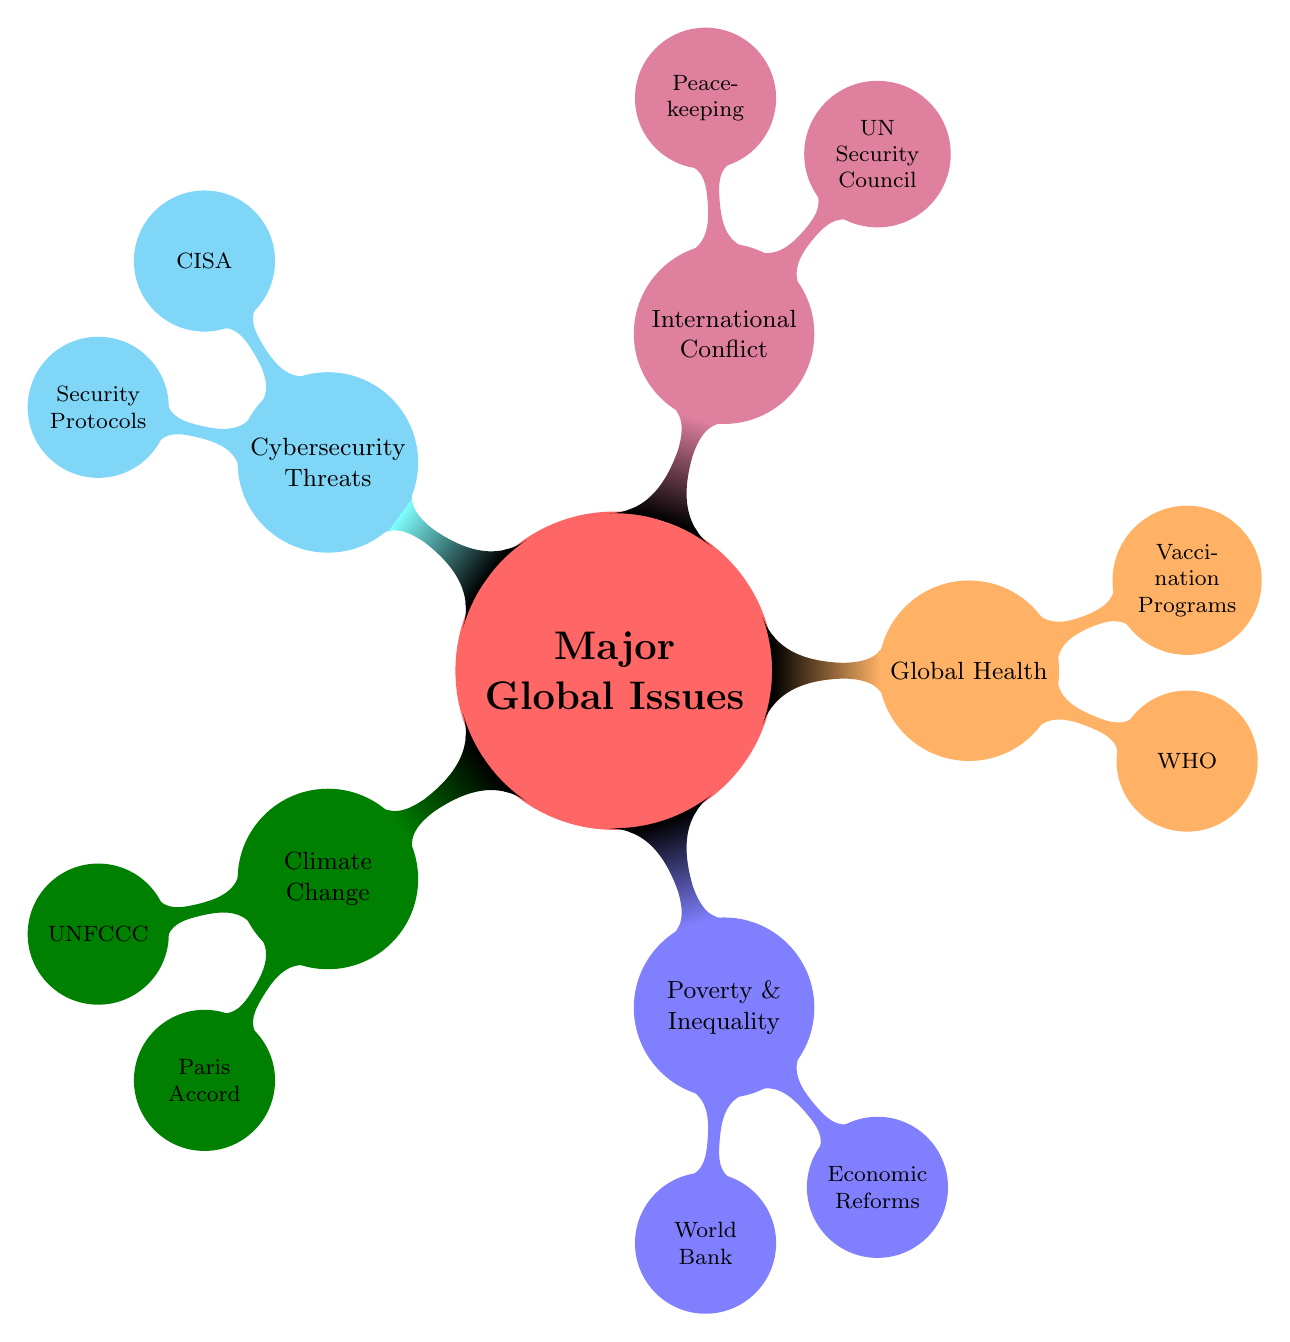What is the first major global issue listed in the diagram? The first issue appears at the top of the mind map under the title "Major Global Issues." It is labeled as "Climate Change."
Answer: Climate Change How many key organizations are listed under "Global Health"? The node for "Global Health" has three child nodes connected to it, which represent the key organizations, thereby indicating the number is three.
Answer: 3 Which organization is associated with "Poverty & Inequality"? The "Poverty & Inequality" node has a child node labeled "World Bank," making it a primary organization associated with this issue.
Answer: World Bank What are the two key solutions mentioned under "International Conflict"? Under the "International Conflict" node, there are two child nodes: "Peacekeeping missions" and "Diplomatic interventions," which are the solutions presented.
Answer: Peacekeeping missions, Diplomatic interventions Which global issue has the key organization "CISA"? The node labeled for "Cybersecurity Threats" directly connects to the child node with "CISA," which makes it the relevant global issue associated with that organization.
Answer: Cybersecurity Threats How many main issues are identified in the diagram? The diagram has five branches stemming from the main node "Major Global Issues," indicating that there are five identified major issues.
Answer: 5 Which major global issue includes "Universal healthcare access" in its solutions? Looking at the solutions under each issue, "Universal healthcare access" is listed as one of the key solutions under the "Global Health" node.
Answer: Global Health What is the purpose of the "Intergovernmental Panel on Climate Change" according to the diagram? The diagram does not explicitly state the purpose of the "Intergovernmental Panel on Climate Change"; however, by being listed under "Climate Change," it suggests that its role is related to addressing climate issues.
Answer: Climate Change What color represents the "Cybersecurity Threats" node? The "Cybersecurity Threats" node is colored cyan according to the specified color scheme in the diagram.
Answer: Cyan 